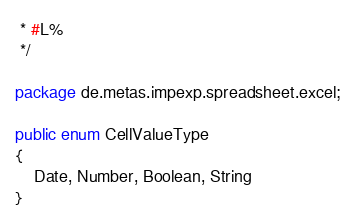Convert code to text. <code><loc_0><loc_0><loc_500><loc_500><_Java_> * #L%
 */

package de.metas.impexp.spreadsheet.excel;

public enum CellValueType
{
	Date, Number, Boolean, String
}
</code> 